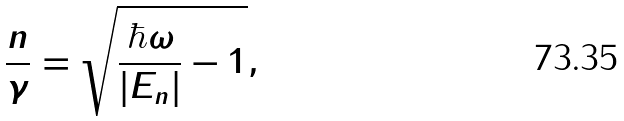Convert formula to latex. <formula><loc_0><loc_0><loc_500><loc_500>\frac { n } { \gamma } = \sqrt { \frac { \hbar { \omega } } { | E _ { n } | } - 1 } ,</formula> 